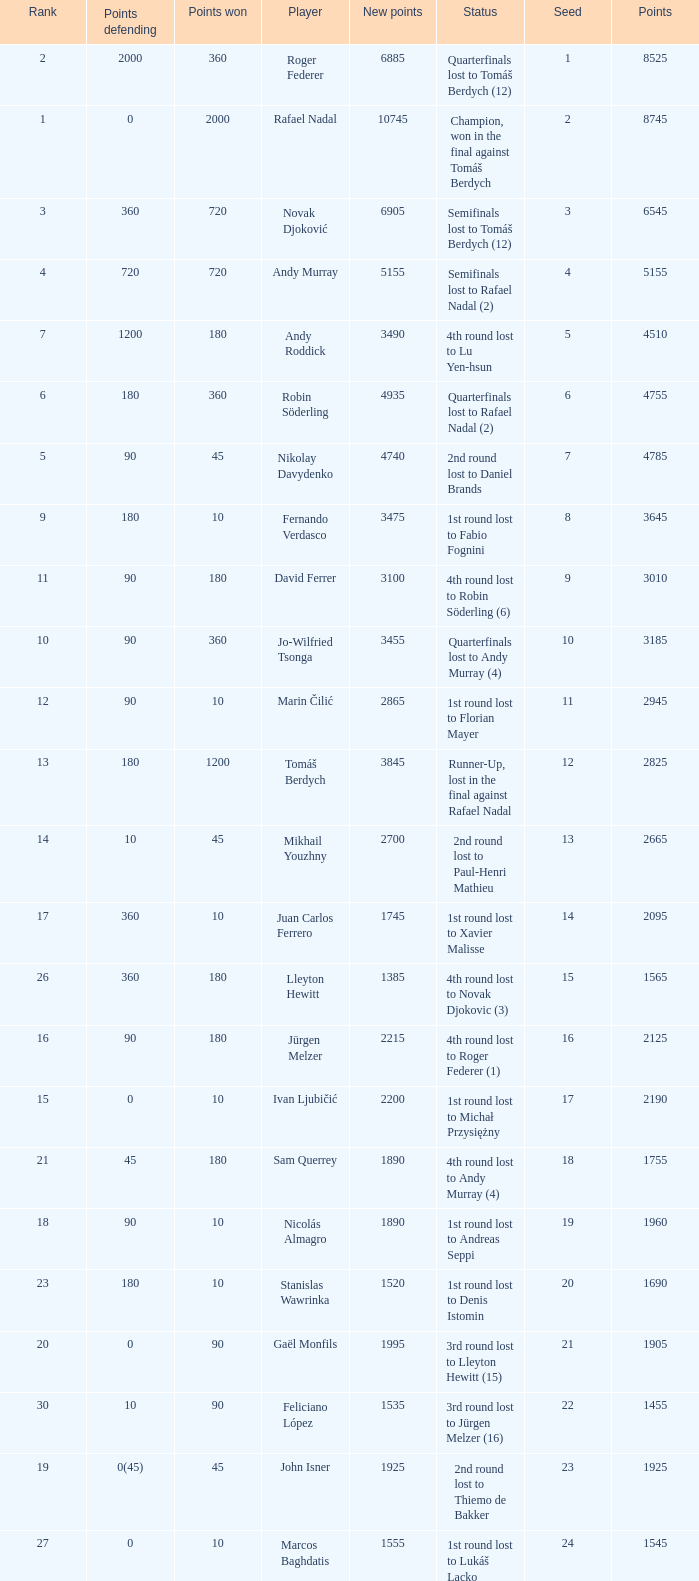Name the number of points defending for 1075 1.0. 